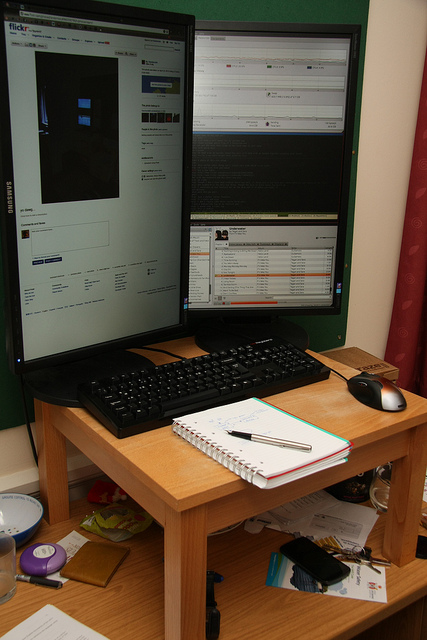<image>What are the computers on? I don't know what the computers are on for sure. It could be a table or desk. What are the computers on? I don't know what the computers are on. It can be either a table or a desk. 